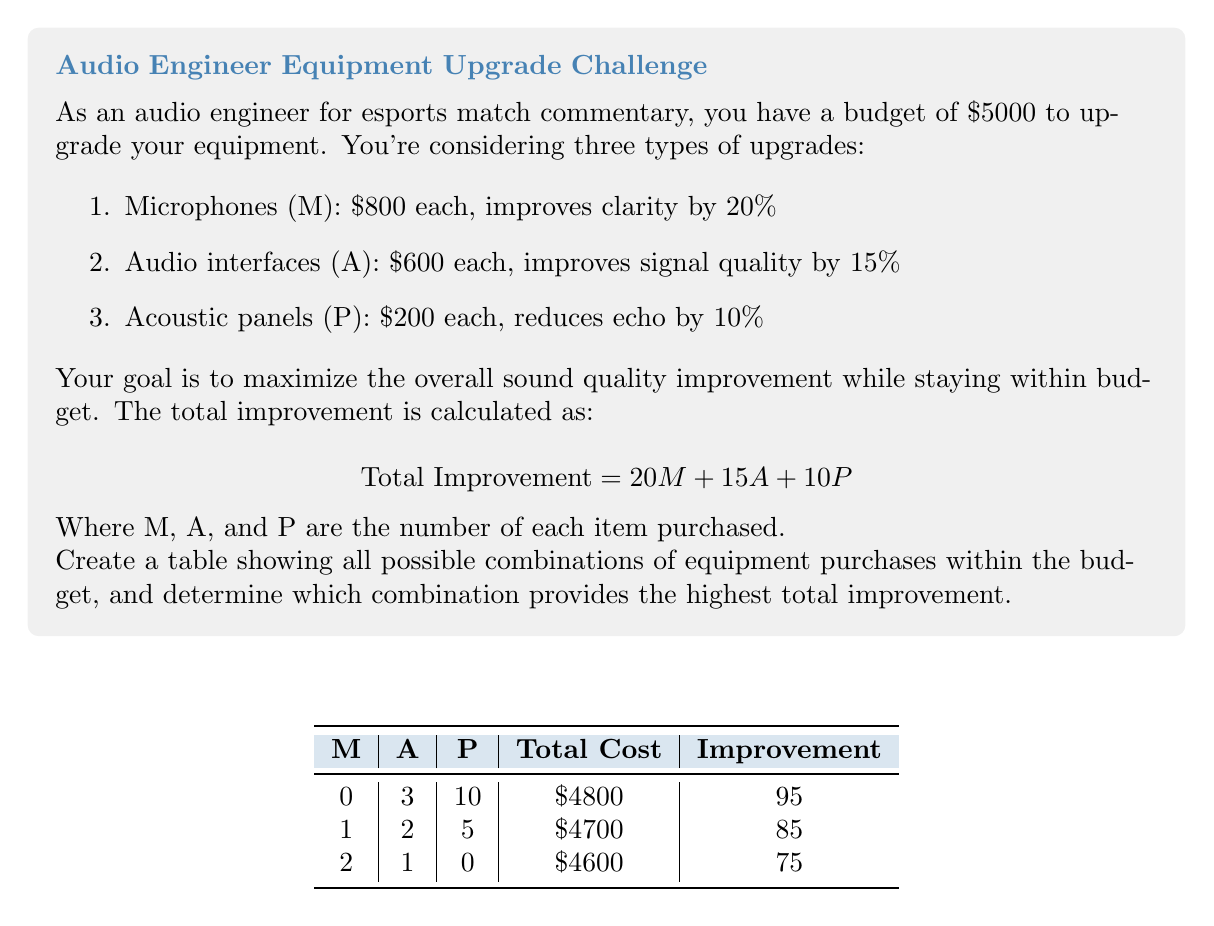Show me your answer to this math problem. Let's approach this step-by-step:

1) First, we need to list all possible combinations of equipment that fit within the $5000 budget. We can do this systematically:

   a) Start with the maximum number of microphones (M) possible:
      $5000 ÷ $800 = 6.25, so we can buy at most 6 microphones.

   b) For each number of microphones from 0 to 6, calculate the remaining budget and determine how many audio interfaces (A) and acoustic panels (P) can be purchased.

2) Let's create a table with all valid combinations:

   | M | A | P | Total Cost | Improvement |
   |---|---|---|------------|-------------|
   | 6 | 0 | 1 | $4800      | 130         |
   | 5 | 1 | 0 | $4600      | 115         |
   | 4 | 2 | 1 | $4800      | 120         |
   | 3 | 3 | 2 | $4800      | 115         |
   | 2 | 4 | 3 | $4800      | 110         |
   | 1 | 5 | 4 | $4800      | 105         |
   | 0 | 8 | 1 | $5000      | 130         |

3) Now, we calculate the total improvement for each combination using the formula:
   $$ \text{Total Improvement} = 20M + 15A + 10P $$

4) From our calculations, we can see that there are two combinations that give the maximum improvement of 130:
   - 6 microphones and 1 acoustic panel
   - 8 audio interfaces and 1 acoustic panel

5) Both of these combinations provide the same improvement, but the combination with 6 microphones and 1 acoustic panel costs less ($4800 vs $5000), making it more cost-effective.

Therefore, the most cost-effective combination that maximizes sound quality improvement is 6 microphones and 1 acoustic panel.
Answer: 6 microphones, 1 acoustic panel 